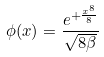Convert formula to latex. <formula><loc_0><loc_0><loc_500><loc_500>\phi ( x ) = \frac { e ^ { + \frac { x ^ { 8 } } { 8 } } } { \sqrt { 8 \beta } }</formula> 